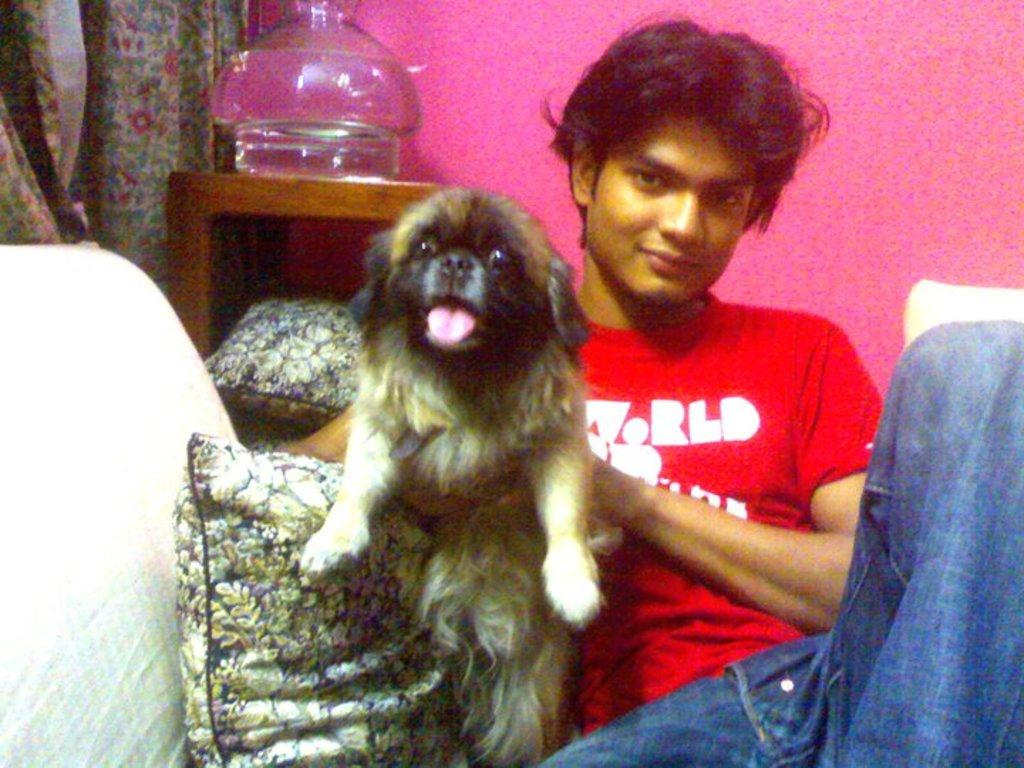What is the boy in the image doing? The boy is sitting in the image. What is the boy holding in the image? The boy is holding a dog in the image. What can be seen on the furniture in the image? There are pillows in the image. What color is the wall in the image? The wall in the image is pink. What type of window treatment is present in the image? There is a curtain in the image. What is the object in the image? There is an object in the image, but its specific nature is not mentioned in the facts. What is written on the boy's t-shirt? Something is written on the boy's red t-shirt. How far away are the cows from the boy in the image? There are no cows present in the image, so it is not possible to determine their distance from the boy. 